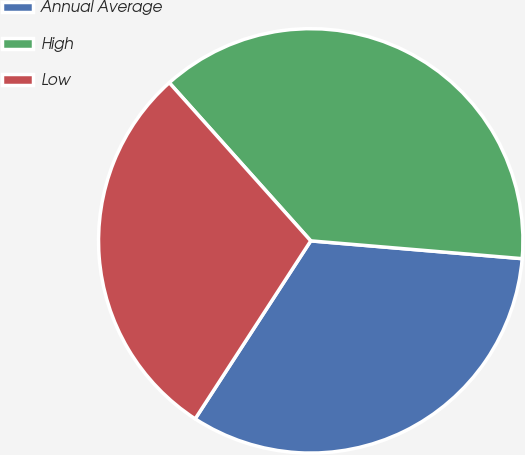Convert chart to OTSL. <chart><loc_0><loc_0><loc_500><loc_500><pie_chart><fcel>Annual Average<fcel>High<fcel>Low<nl><fcel>32.83%<fcel>37.95%<fcel>29.22%<nl></chart> 